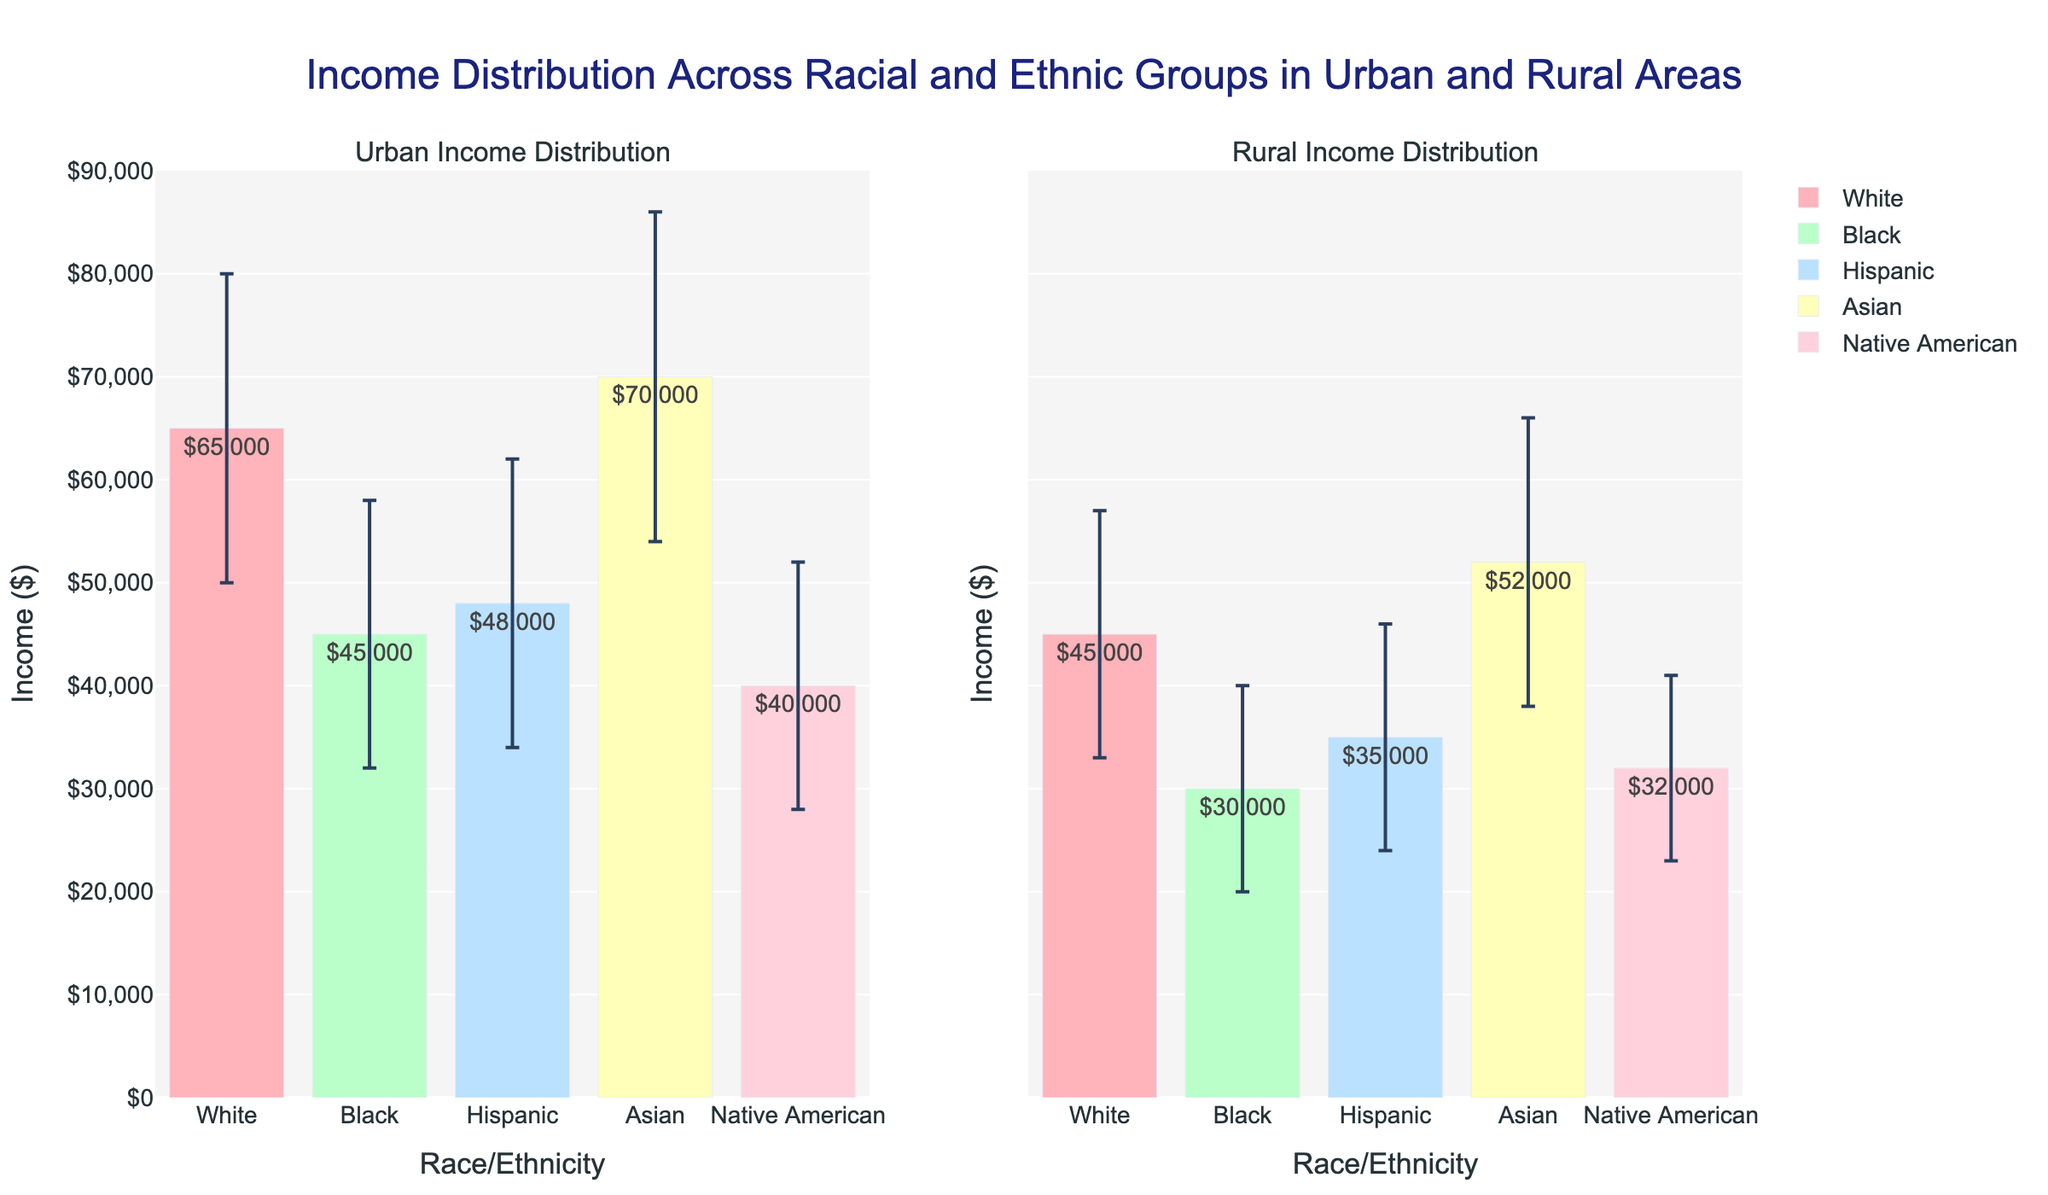Which racial or ethnic group has the highest mean income in urban areas? By looking at the urban subplot, the Asian bar has the highest income mean value visible in the bar chart.
Answer: Asian Which racial or ethnic group has the highest variance in income in rural areas? Variance can be inferred from the length of the error bars. In rural areas, the Asian group has the longest error bars, indicating the highest standard deviation and hence the highest variance.
Answer: Asian How much greater is the mean income for Whites in urban areas compared to rural areas? The mean income for Whites in urban areas is $65,000, and in rural areas, it is $45,000. The difference is $65,000 - $45,000 = $20,000.
Answer: $20,000 Which racial or ethnic group has the lowest mean income in rural areas? Looking at the rural subplot, the Black group has the lowest bar which indicates the lowest mean income.
Answer: Black What is the difference in mean income between Hispanics in urban areas and Native Americans in rural areas? The mean income for Hispanics in urban areas is $48,000, and for Native Americans in rural areas, it is $32,000. The difference is $48,000 - $32,000 = $16,000.
Answer: $16,000 Which location, urban or rural, shows a greater range in the mean income across all racial and ethnic groups? Comparing the height of the bars in both subplots, the urban areas have a larger range from the lowest to the highest mean income ($30,000 to $70,000) compared to rural areas ($30,000 to $52,000).
Answer: Urban What does the length of the error bars represent in this figure? The error bars indicate the standard deviation of the income within each racial and ethnic group, showing the variability or spread around the mean income.
Answer: Standard deviation Which racial or ethnic group has a higher mean income in urban areas compared to their rural counterparts? For all racial and ethnic groups, the mean income in urban areas is higher than in rural areas as seen by comparing the height of the bars between the two subplots.
Answer: All groups 